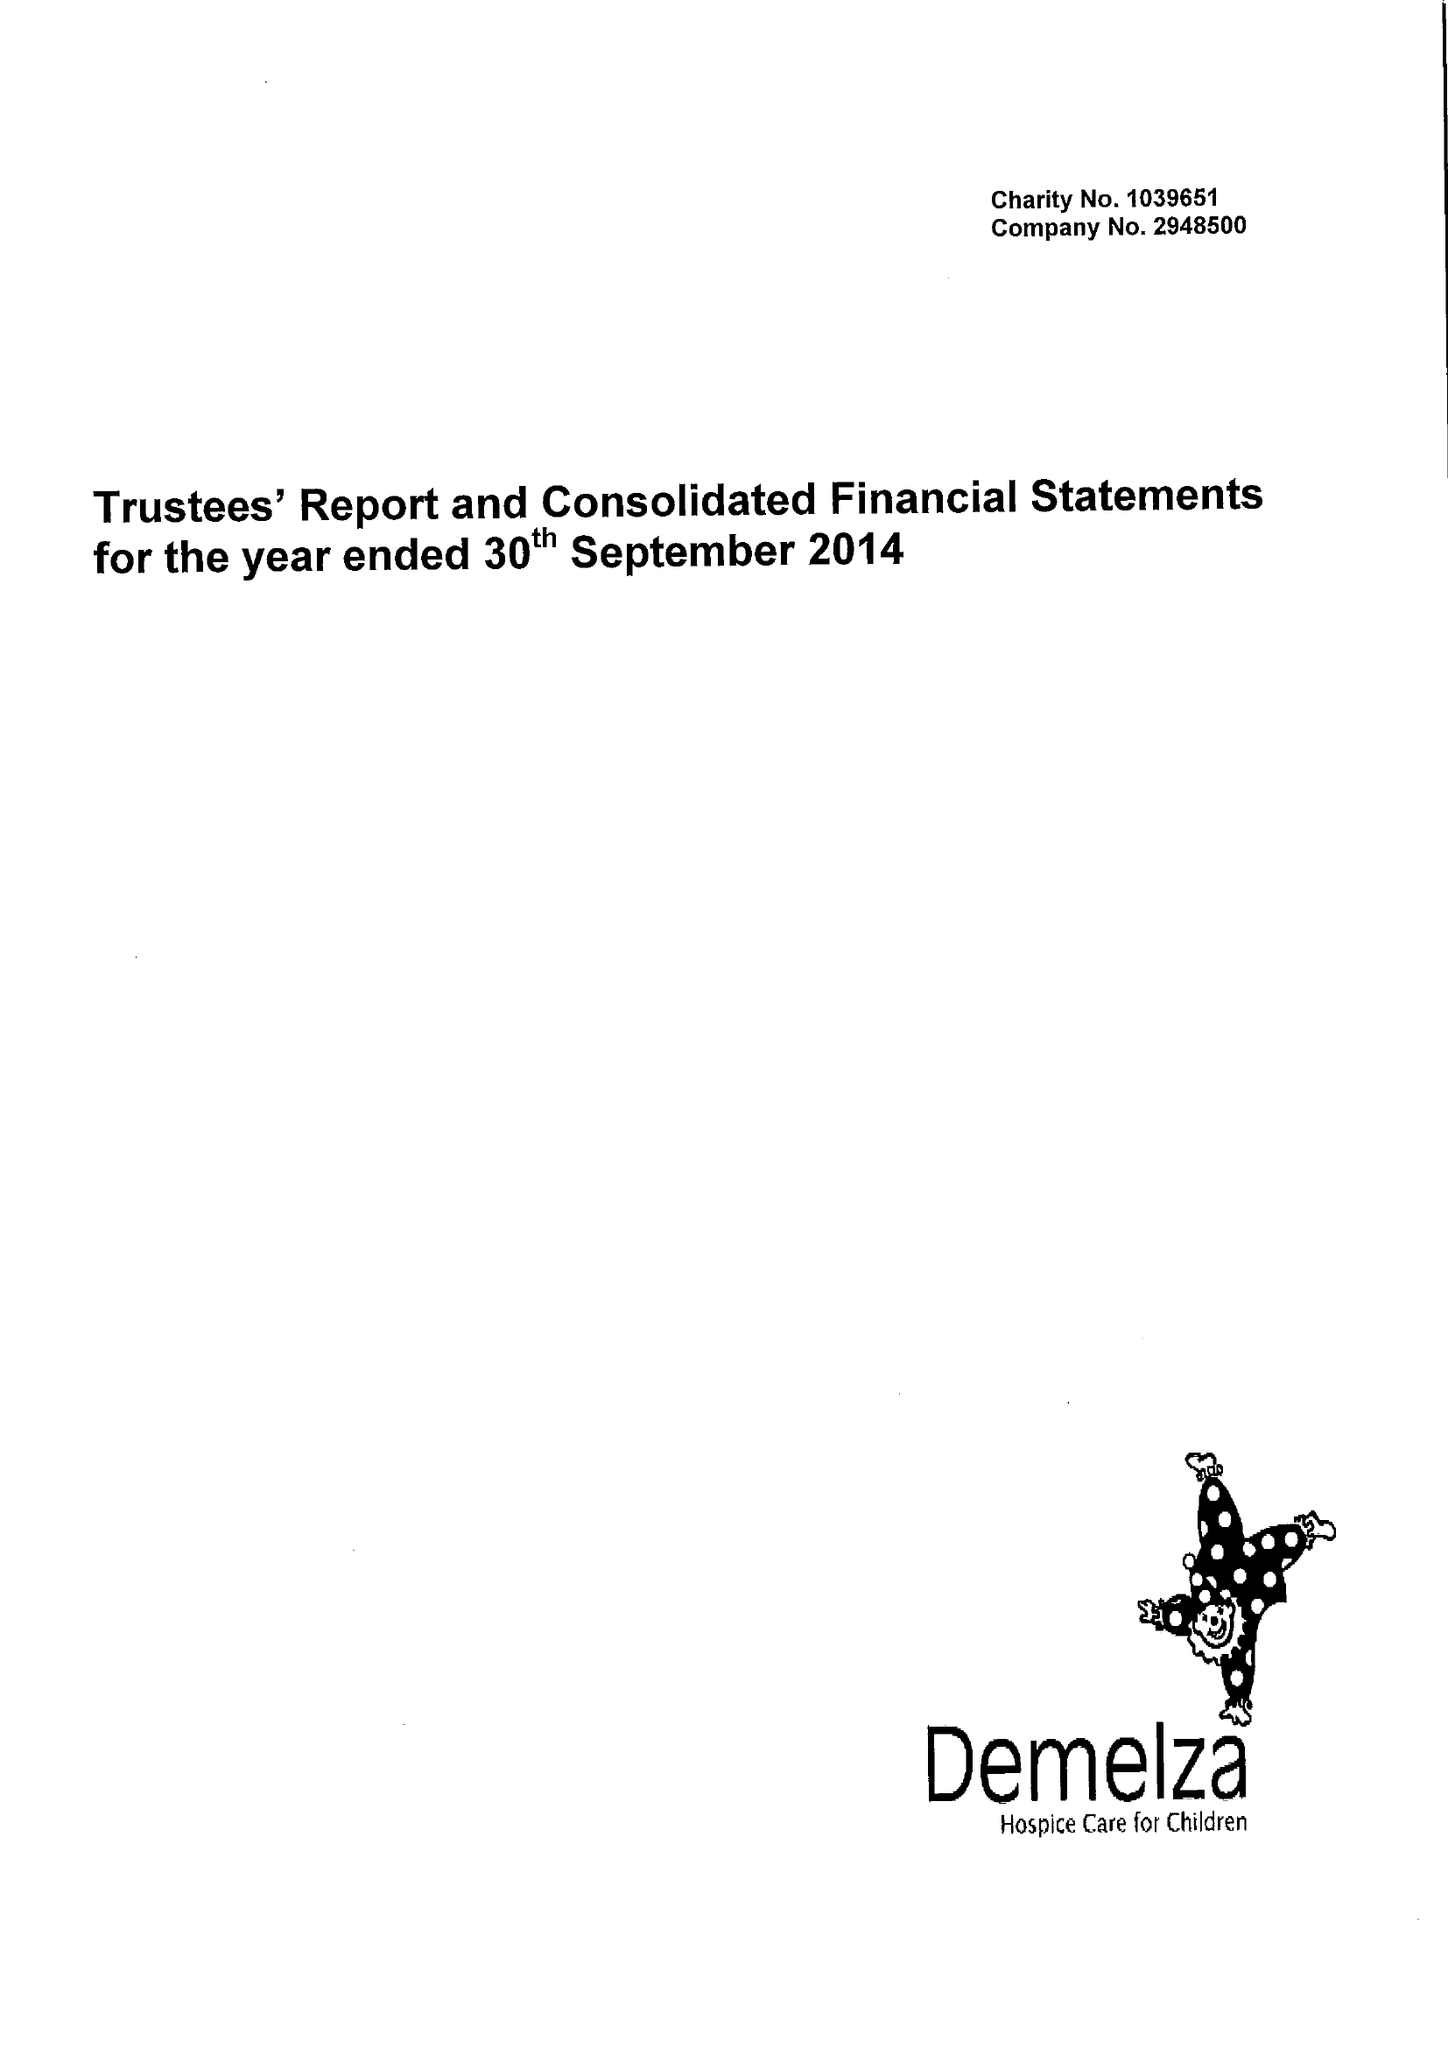What is the value for the address__post_town?
Answer the question using a single word or phrase. SITTINGBOURNE 